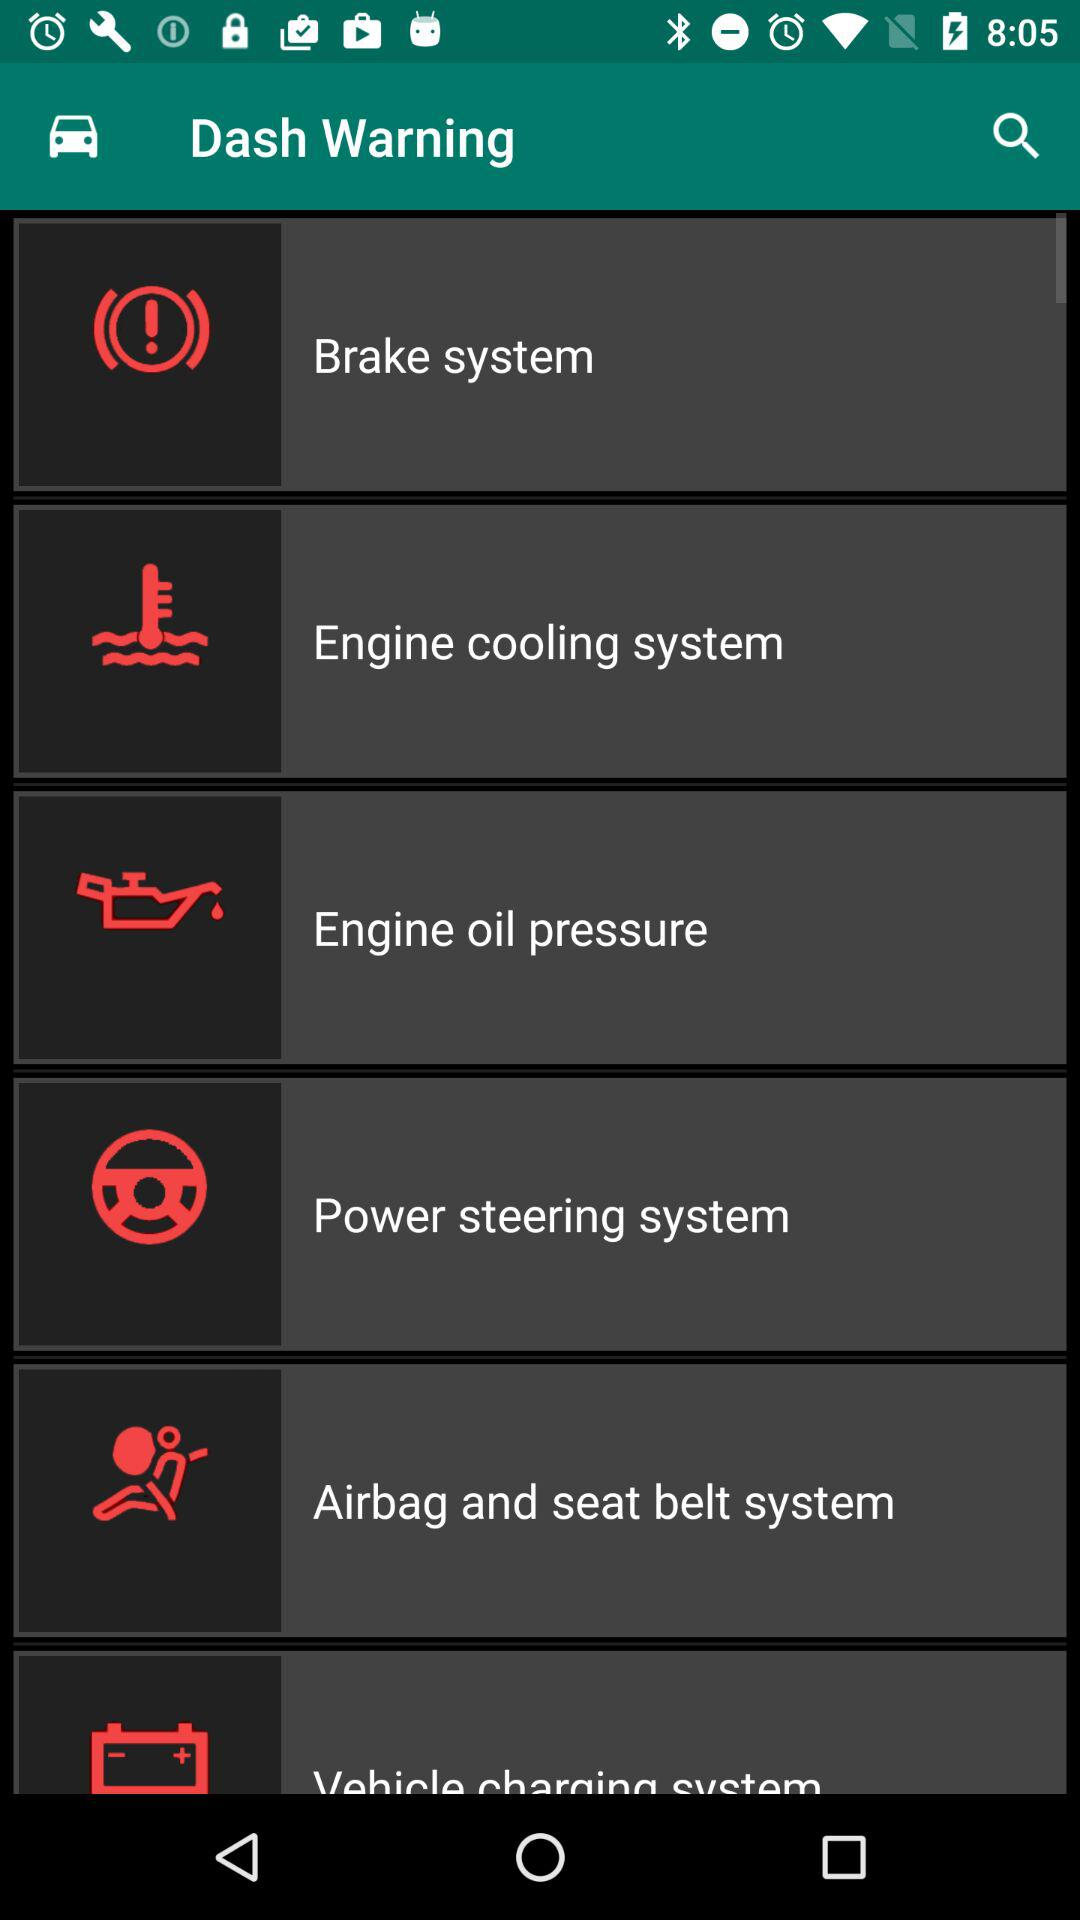How many warning lights are there for the power steering and the airbag system?
Answer the question using a single word or phrase. 2 